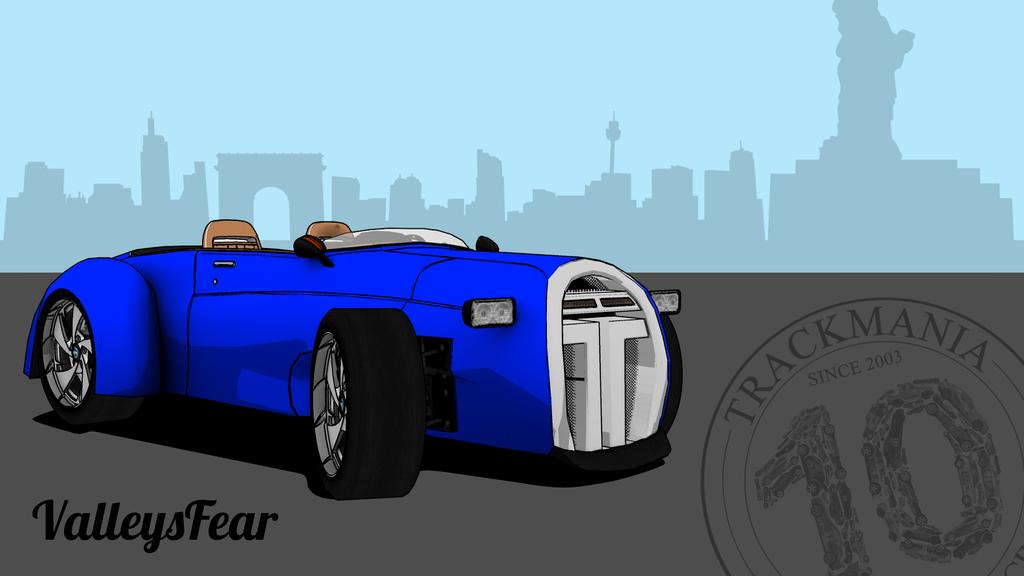What type of visual content is depicted in the image? The image is an animation. What is the main subject in the center of the image? There is a vehicle in the center of the image. What can be seen in the background of the image? There are buildings and towers in the background of the image. Are there any words or letters present in the image? Yes, there is text present in the image. What type of cap is worn by the person standing next to the cemetery in the image? There is no person or cemetery present in the image. 